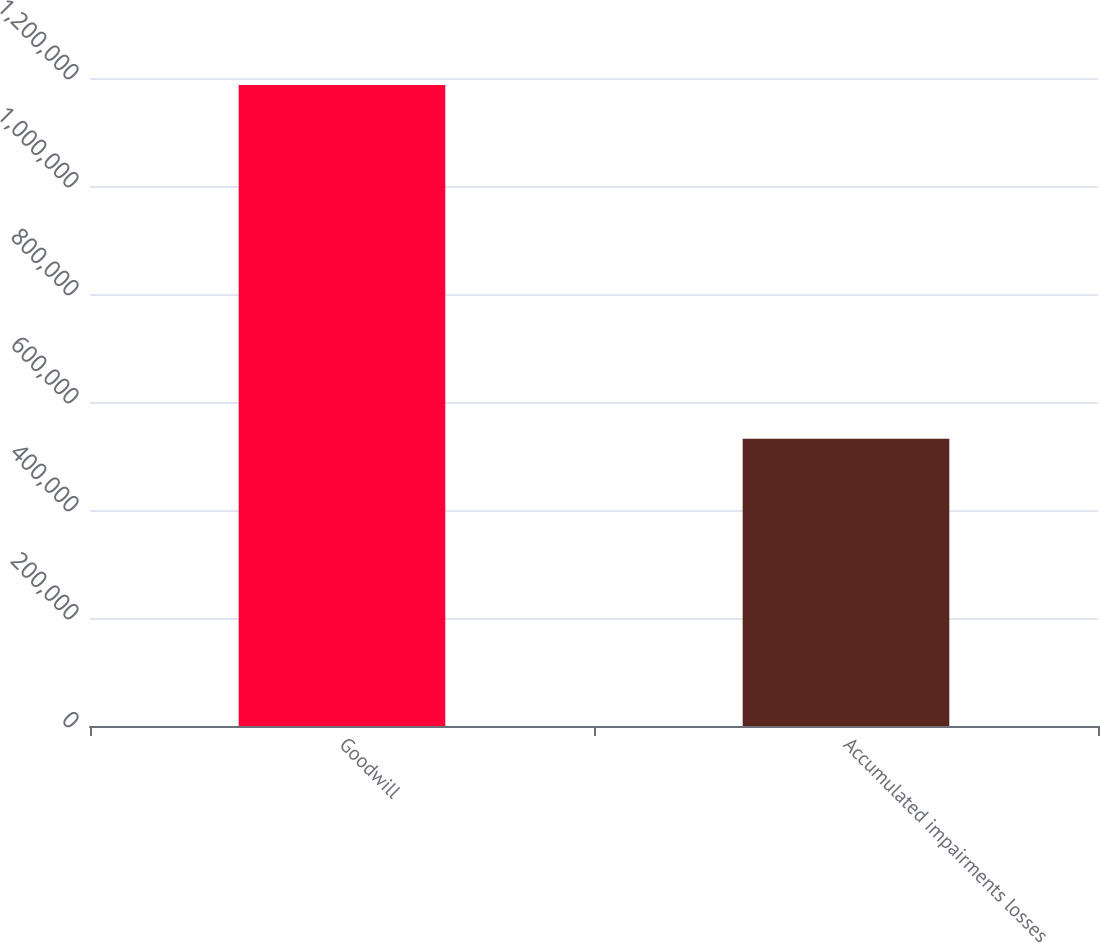Convert chart to OTSL. <chart><loc_0><loc_0><loc_500><loc_500><bar_chart><fcel>Goodwill<fcel>Accumulated impairments losses<nl><fcel>1.18691e+06<fcel>531930<nl></chart> 